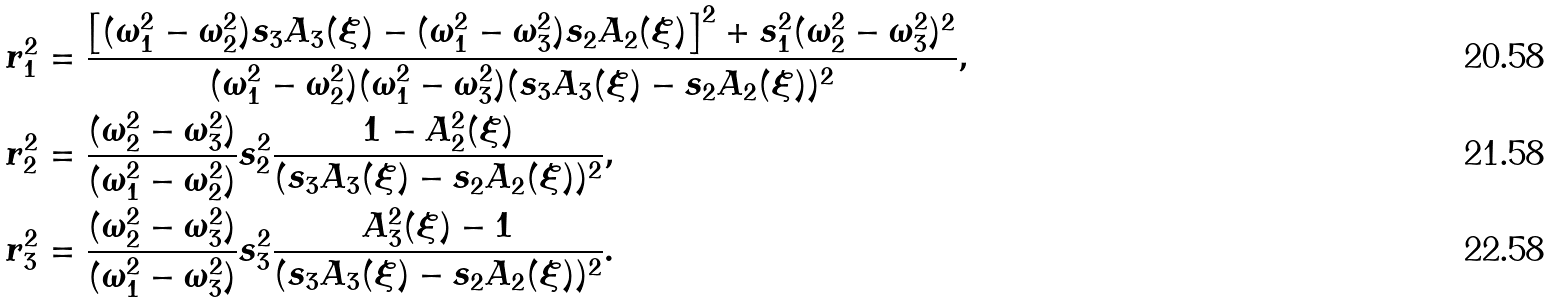Convert formula to latex. <formula><loc_0><loc_0><loc_500><loc_500>& r _ { 1 } ^ { 2 } = \frac { \left [ ( \omega _ { 1 } ^ { 2 } - \omega _ { 2 } ^ { 2 } ) s _ { 3 } A _ { 3 } ( \xi ) - ( \omega _ { 1 } ^ { 2 } - \omega _ { 3 } ^ { 2 } ) s _ { 2 } A _ { 2 } ( \xi ) \right ] ^ { 2 } + s _ { 1 } ^ { 2 } ( \omega _ { 2 } ^ { 2 } - \omega _ { 3 } ^ { 2 } ) ^ { 2 } } { ( \omega _ { 1 } ^ { 2 } - \omega _ { 2 } ^ { 2 } ) ( \omega _ { 1 } ^ { 2 } - \omega _ { 3 } ^ { 2 } ) ( s _ { 3 } A _ { 3 } ( \xi ) - s _ { 2 } A _ { 2 } ( \xi ) ) ^ { 2 } } , \\ & r _ { 2 } ^ { 2 } = \frac { ( \omega _ { 2 } ^ { 2 } - \omega _ { 3 } ^ { 2 } ) } { ( \omega _ { 1 } ^ { 2 } - \omega _ { 2 } ^ { 2 } ) } s _ { 2 } ^ { 2 } \frac { 1 - A _ { 2 } ^ { 2 } ( \xi ) } { ( s _ { 3 } A _ { 3 } ( \xi ) - s _ { 2 } A _ { 2 } ( \xi ) ) ^ { 2 } } , \\ & r _ { 3 } ^ { 2 } = \frac { ( \omega _ { 2 } ^ { 2 } - \omega _ { 3 } ^ { 2 } ) } { ( \omega _ { 1 } ^ { 2 } - \omega _ { 3 } ^ { 2 } ) } s _ { 3 } ^ { 2 } \frac { A _ { 3 } ^ { 2 } ( \xi ) - 1 } { ( s _ { 3 } A _ { 3 } ( \xi ) - s _ { 2 } A _ { 2 } ( \xi ) ) ^ { 2 } } .</formula> 